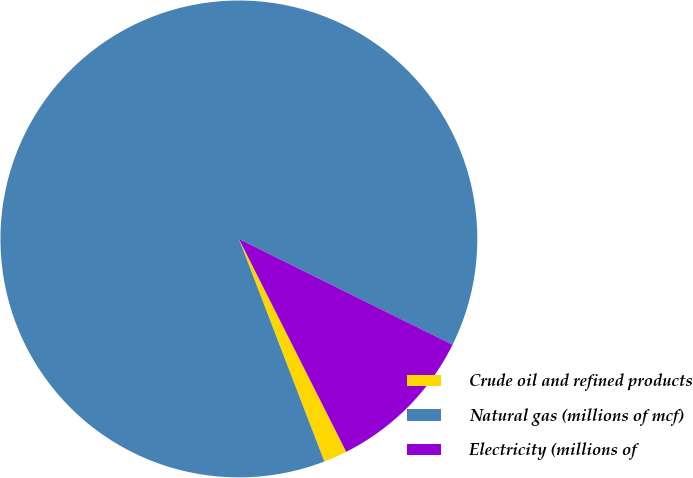<chart> <loc_0><loc_0><loc_500><loc_500><pie_chart><fcel>Crude oil and refined products<fcel>Natural gas (millions of mcf)<fcel>Electricity (millions of<nl><fcel>1.6%<fcel>88.15%<fcel>10.25%<nl></chart> 